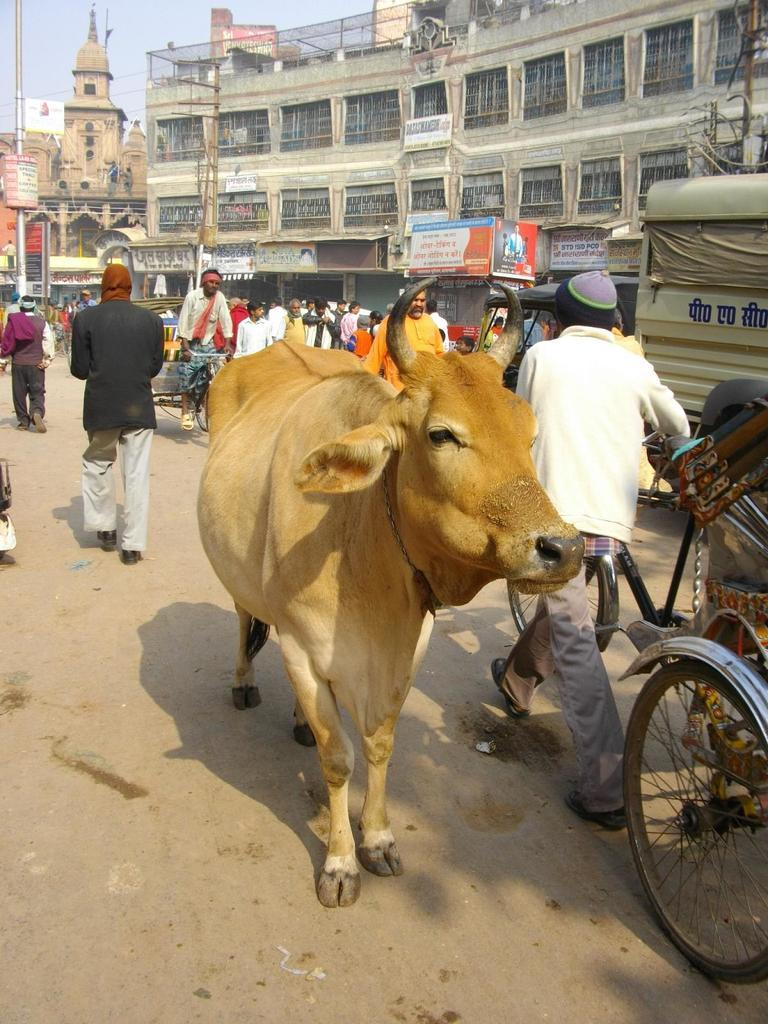What is the main feature of the image? There is a road in the image. What can be seen on the road? A cow and vehicles are present on the road. Are there any people in the image? Yes, people are on the road. What else can be seen in the image besides the road? There are buildings visible in the image, some of which have boards. Can you tell me how many buttons are on the cow's back in the image? There are no buttons present on the cow's back in the image. Is there a fight happening between the people on the road in the image? There is no fight depicted in the image; people are simply present on the road. 